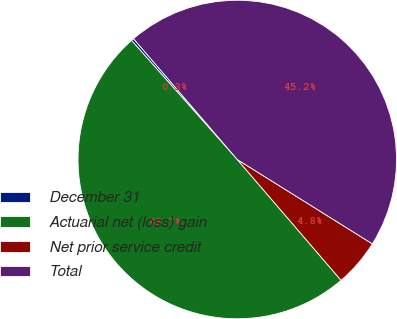Convert chart to OTSL. <chart><loc_0><loc_0><loc_500><loc_500><pie_chart><fcel>December 31<fcel>Actuarial net (loss) gain<fcel>Net prior service credit<fcel>Total<nl><fcel>0.26%<fcel>49.74%<fcel>4.82%<fcel>45.18%<nl></chart> 